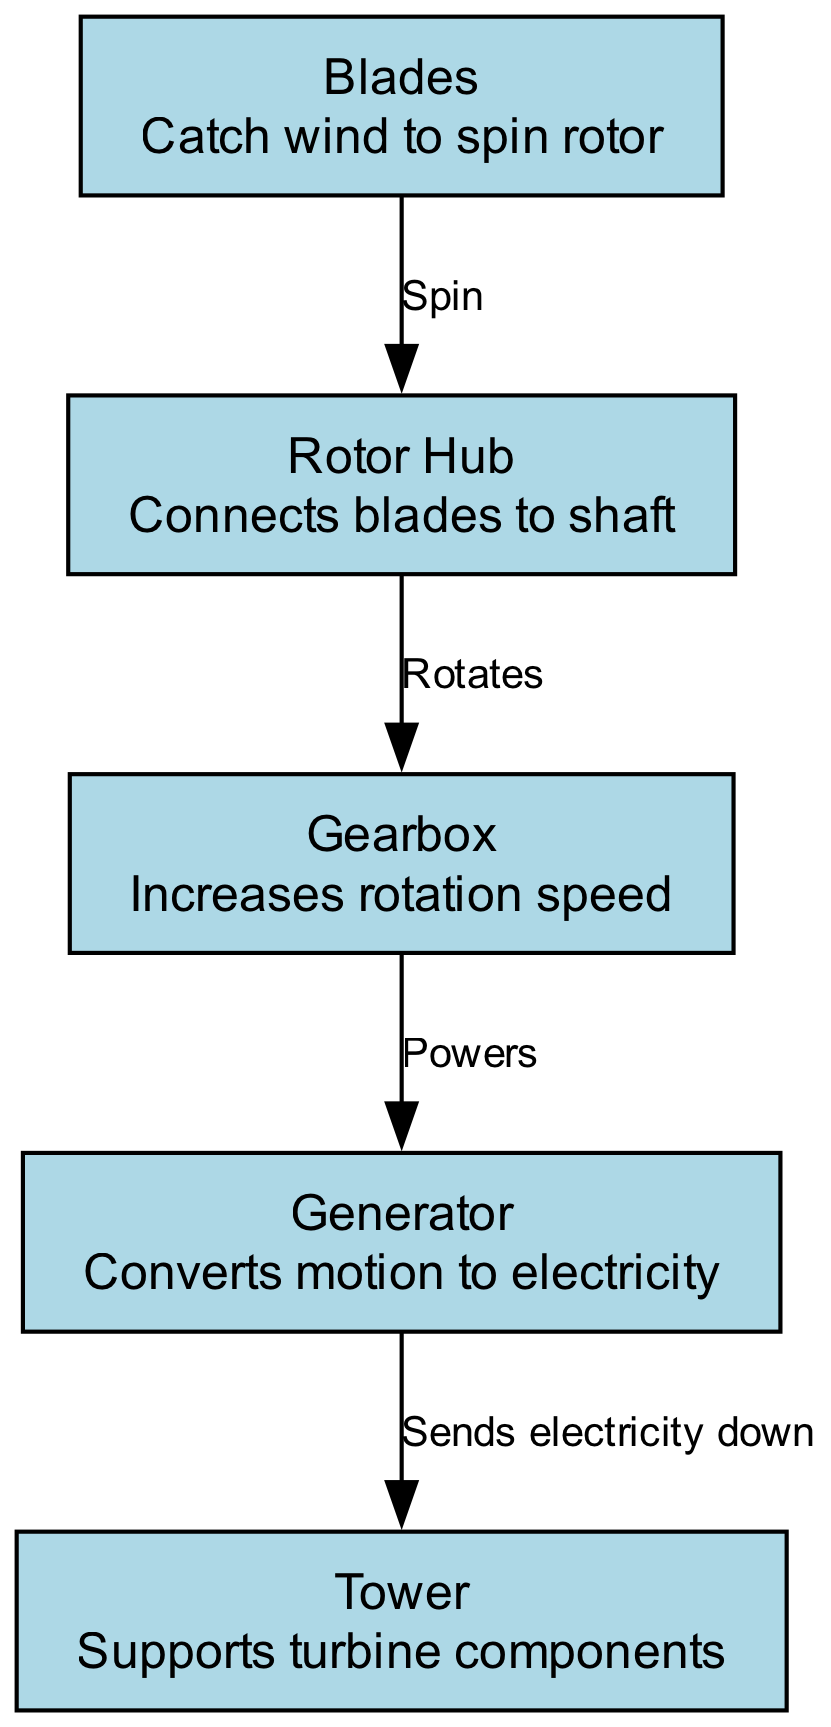What is the function of the blades? The blades catch the wind to spin the rotor, which is their primary function in the wind turbine.
Answer: Catch wind to spin rotor How many nodes are in the diagram? By counting the unique labeled components in the diagram, there are a total of five nodes present.
Answer: 5 What connects the blades to the rotor hub? The rotor hub serves as the component that connects the blades directly to the rotor, facilitating their movement together.
Answer: Rotor hub What does the gearbox do? The gearbox increases the rotation speed, which is crucial for effective power generation in the wind turbine.
Answer: Increases rotation speed Where does electricity go after the generator? After the generator converts motion to electricity, it sends the electricity down to the tower for distribution.
Answer: Sends electricity down Which node is responsible for converting motion to electricity? The generator is the dedicated component that takes the mechanical motion from the gearbox and converts it into electrical energy.
Answer: Generator What is the relationship between the rotor hub and the gearbox? The rotor hub rotates, which drives the gearbox by passing the rotational energy from the blades through the rotor.
Answer: Rotates What supports the turbine components? The tower is specifically designed to support all the turbine components, providing stability and height for optimal wind capture.
Answer: Tower Which component powers the generator? The gearbox powers the generator by transferring the increased rotational speed necessary for electricity generation.
Answer: Powers 